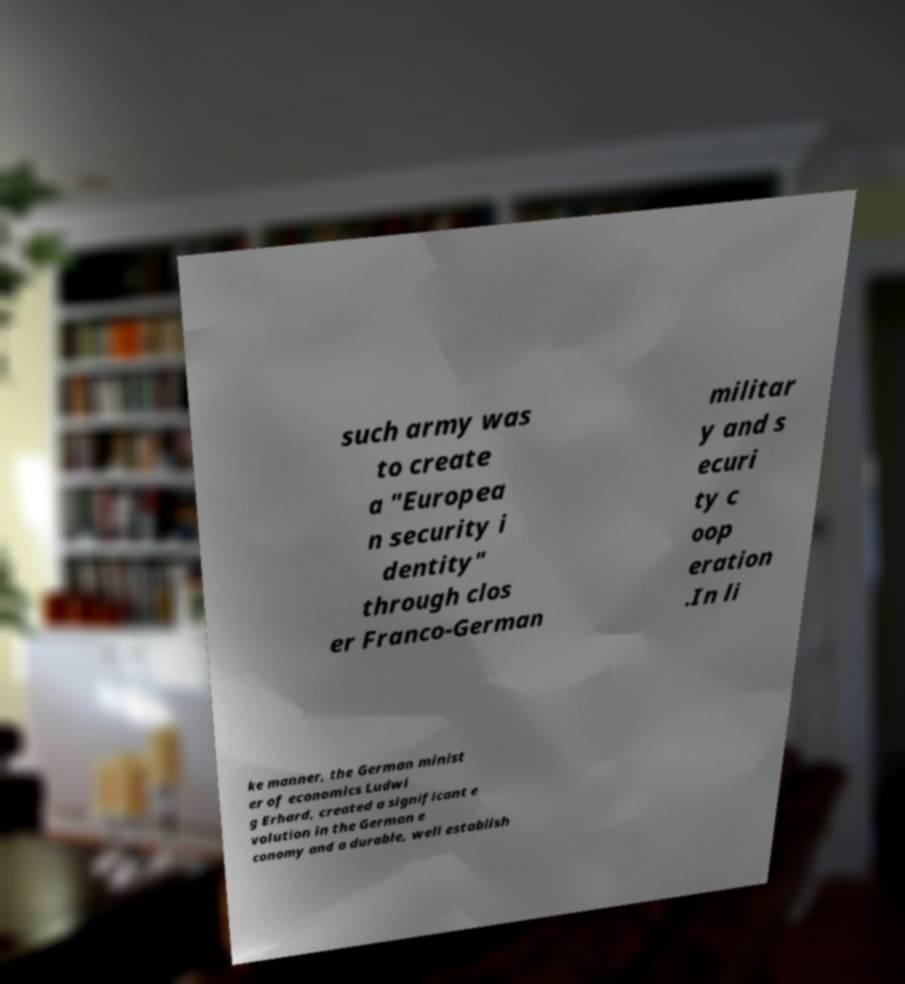Can you read and provide the text displayed in the image?This photo seems to have some interesting text. Can you extract and type it out for me? such army was to create a "Europea n security i dentity" through clos er Franco-German militar y and s ecuri ty c oop eration .In li ke manner, the German minist er of economics Ludwi g Erhard, created a significant e volution in the German e conomy and a durable, well establish 